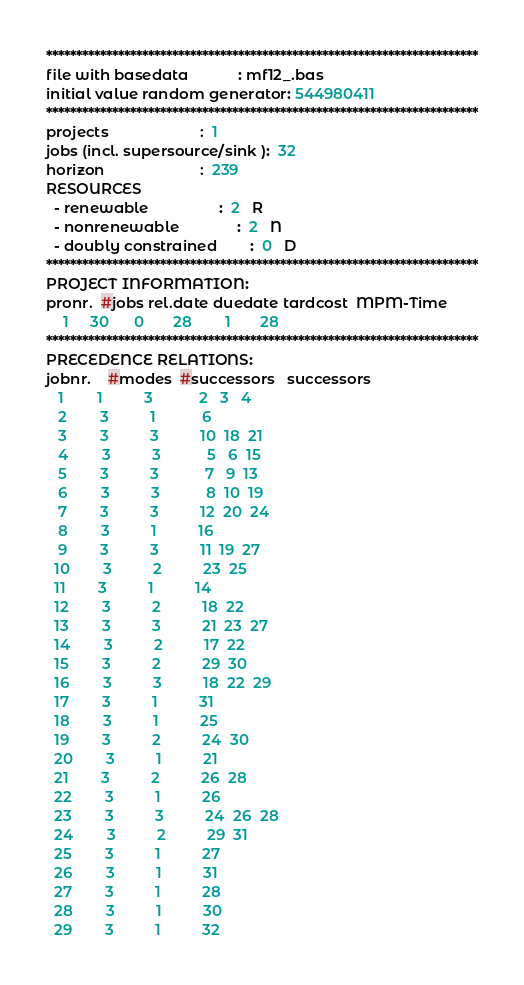<code> <loc_0><loc_0><loc_500><loc_500><_ObjectiveC_>************************************************************************
file with basedata            : mf12_.bas
initial value random generator: 544980411
************************************************************************
projects                      :  1
jobs (incl. supersource/sink ):  32
horizon                       :  239
RESOURCES
  - renewable                 :  2   R
  - nonrenewable              :  2   N
  - doubly constrained        :  0   D
************************************************************************
PROJECT INFORMATION:
pronr.  #jobs rel.date duedate tardcost  MPM-Time
    1     30      0       28        1       28
************************************************************************
PRECEDENCE RELATIONS:
jobnr.    #modes  #successors   successors
   1        1          3           2   3   4
   2        3          1           6
   3        3          3          10  18  21
   4        3          3           5   6  15
   5        3          3           7   9  13
   6        3          3           8  10  19
   7        3          3          12  20  24
   8        3          1          16
   9        3          3          11  19  27
  10        3          2          23  25
  11        3          1          14
  12        3          2          18  22
  13        3          3          21  23  27
  14        3          2          17  22
  15        3          2          29  30
  16        3          3          18  22  29
  17        3          1          31
  18        3          1          25
  19        3          2          24  30
  20        3          1          21
  21        3          2          26  28
  22        3          1          26
  23        3          3          24  26  28
  24        3          2          29  31
  25        3          1          27
  26        3          1          31
  27        3          1          28
  28        3          1          30
  29        3          1          32</code> 